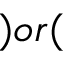Convert formula to latex. <formula><loc_0><loc_0><loc_500><loc_500>) o r (</formula> 